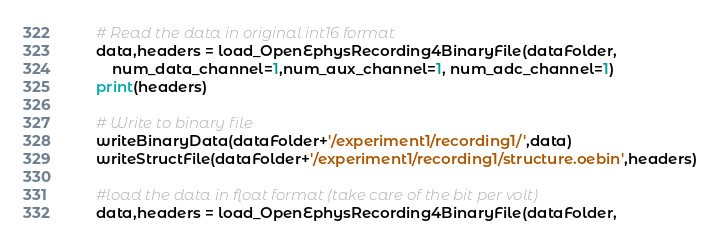<code> <loc_0><loc_0><loc_500><loc_500><_Python_>
    # Read the data in original int16 format
    data,headers = load_OpenEphysRecording4BinaryFile(dataFolder,
        num_data_channel=1,num_aux_channel=1, num_adc_channel=1)
    print(headers)

    # Write to binary file
    writeBinaryData(dataFolder+'/experiment1/recording1/',data)
    writeStructFile(dataFolder+'/experiment1/recording1/structure.oebin',headers)

    #load the data in float format (take care of the bit per volt)
    data,headers = load_OpenEphysRecording4BinaryFile(dataFolder,</code> 